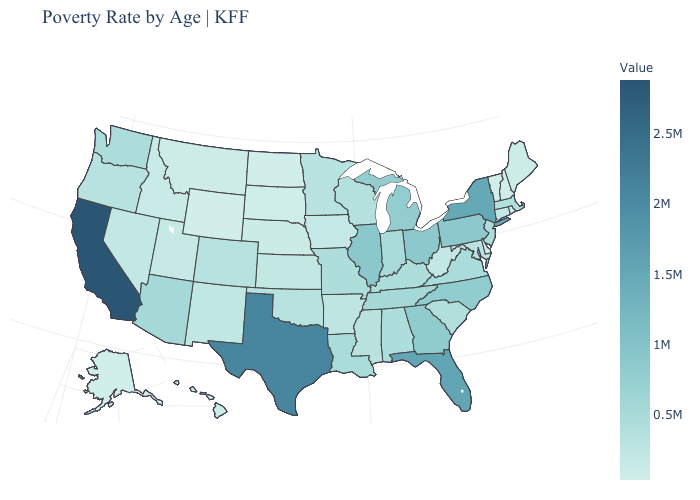Does New York have a lower value than California?
Write a very short answer. Yes. Does Michigan have a lower value than Texas?
Answer briefly. Yes. Among the states that border Arizona , does California have the highest value?
Short answer required. Yes. 